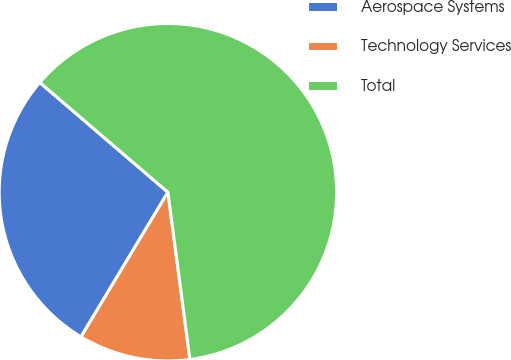Convert chart. <chart><loc_0><loc_0><loc_500><loc_500><pie_chart><fcel>Aerospace Systems<fcel>Technology Services<fcel>Total<nl><fcel>27.66%<fcel>10.7%<fcel>61.64%<nl></chart> 